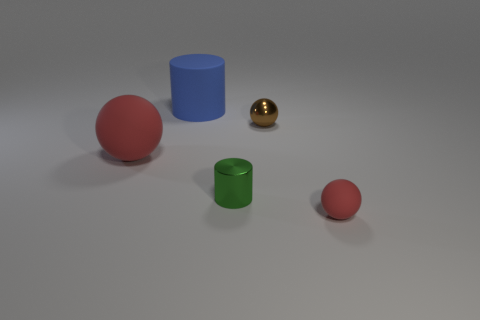Is the number of big cylinders in front of the big matte sphere the same as the number of large things behind the metallic ball?
Ensure brevity in your answer.  No. How many other objects are there of the same material as the small cylinder?
Provide a short and direct response. 1. How many metal objects are either balls or large things?
Offer a very short reply. 1. There is a red rubber thing behind the small red matte sphere; is it the same shape as the small brown shiny thing?
Your answer should be compact. Yes. Is the number of blue matte cylinders that are left of the green cylinder greater than the number of purple blocks?
Your response must be concise. Yes. What number of red spheres are right of the blue matte object and to the left of the green metallic cylinder?
Provide a short and direct response. 0. What color is the small sphere that is behind the red ball that is in front of the big red ball?
Keep it short and to the point. Brown. How many big objects are the same color as the tiny matte object?
Keep it short and to the point. 1. There is a small rubber ball; is its color the same as the big object that is in front of the big blue object?
Offer a very short reply. Yes. Are there fewer tiny green metallic objects than matte objects?
Give a very brief answer. Yes. 